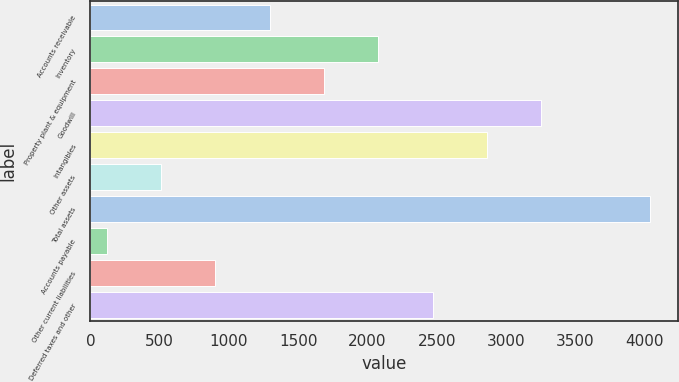<chart> <loc_0><loc_0><loc_500><loc_500><bar_chart><fcel>Accounts receivable<fcel>Inventory<fcel>Property plant & equipment<fcel>Goodwill<fcel>Intangibles<fcel>Other assets<fcel>Total assets<fcel>Accounts payable<fcel>Other current liabilities<fcel>Deferred taxes and other<nl><fcel>1294.1<fcel>2077.5<fcel>1685.8<fcel>3252.6<fcel>2860.9<fcel>510.7<fcel>4036<fcel>119<fcel>902.4<fcel>2469.2<nl></chart> 